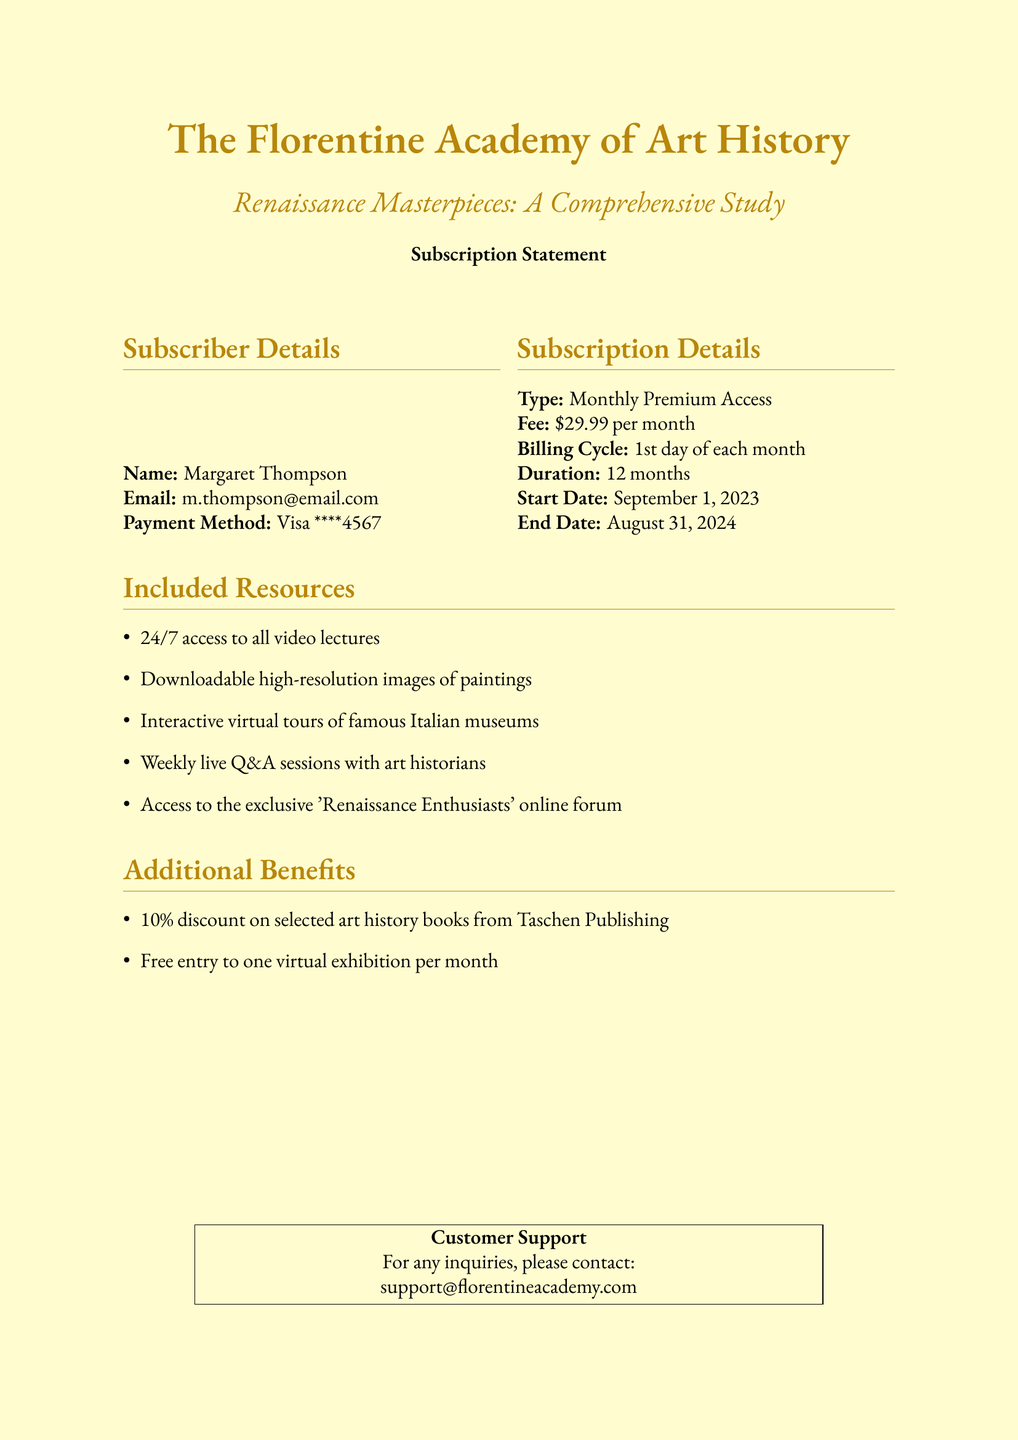What is the subscriber's name? The subscriber's name is mentioned in the details section of the document.
Answer: Margaret Thompson What is the monthly fee for the subscription? The monthly fee is listed in the subscription details of the document.
Answer: $29.99 per month When does the subscription start? The start date is specified in the subscription details section.
Answer: September 1, 2023 How long is the subscription duration? The duration is noted in the subscription details, indicating how long the service lasts.
Answer: 12 months What is one of the included resources? The document lists resources provided with the subscription, indicating various benefits.
Answer: 24/7 access to all video lectures What discount is offered on selected art history books? The additional benefits section contains information about discounts available with the subscription.
Answer: 10\% How often can subscribers attend live Q&A sessions? This information is included in the resources section, detailing the frequency of certain activities.
Answer: Weekly When is the billing cycle set to occur? The billing cycle details are specified in the subscription section of the document.
Answer: 1st day of each month What is the email for customer support? The customer support contact information is given at the end of the document.
Answer: support@florentineacademy.com 